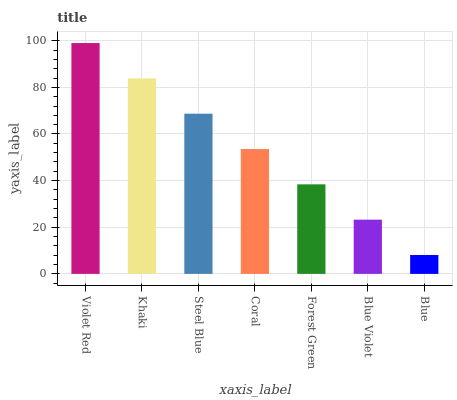Is Khaki the minimum?
Answer yes or no. No. Is Khaki the maximum?
Answer yes or no. No. Is Violet Red greater than Khaki?
Answer yes or no. Yes. Is Khaki less than Violet Red?
Answer yes or no. Yes. Is Khaki greater than Violet Red?
Answer yes or no. No. Is Violet Red less than Khaki?
Answer yes or no. No. Is Coral the high median?
Answer yes or no. Yes. Is Coral the low median?
Answer yes or no. Yes. Is Forest Green the high median?
Answer yes or no. No. Is Violet Red the low median?
Answer yes or no. No. 